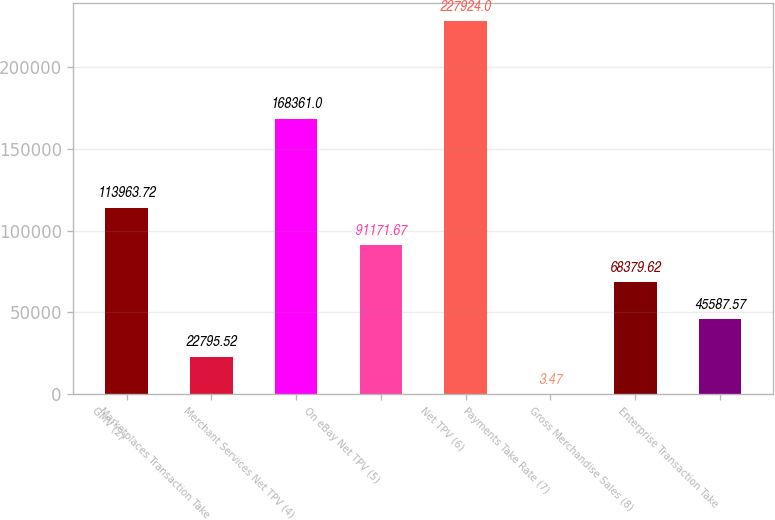<chart> <loc_0><loc_0><loc_500><loc_500><bar_chart><fcel>GMV (2)<fcel>Marketplaces Transaction Take<fcel>Merchant Services Net TPV (4)<fcel>On eBay Net TPV (5)<fcel>Net TPV (6)<fcel>Payments Take Rate (7)<fcel>Gross Merchandise Sales (8)<fcel>Enterprise Transaction Take<nl><fcel>113964<fcel>22795.5<fcel>168361<fcel>91171.7<fcel>227924<fcel>3.47<fcel>68379.6<fcel>45587.6<nl></chart> 